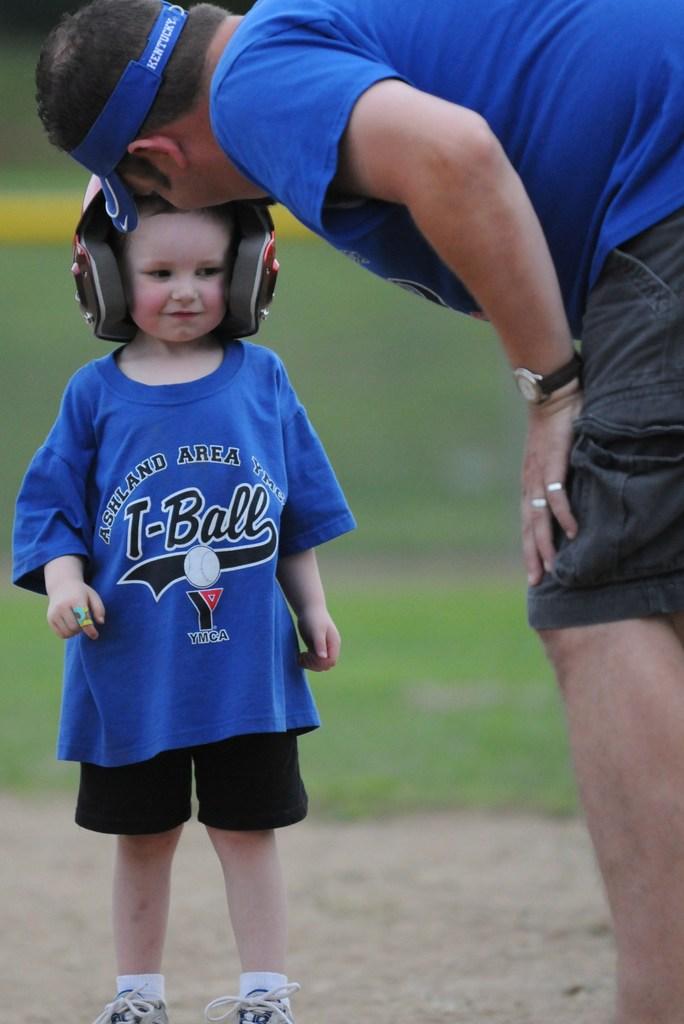What kind of ball is being played?
Your response must be concise. T-ball. What city is the ymca in?
Offer a terse response. Ashland. 